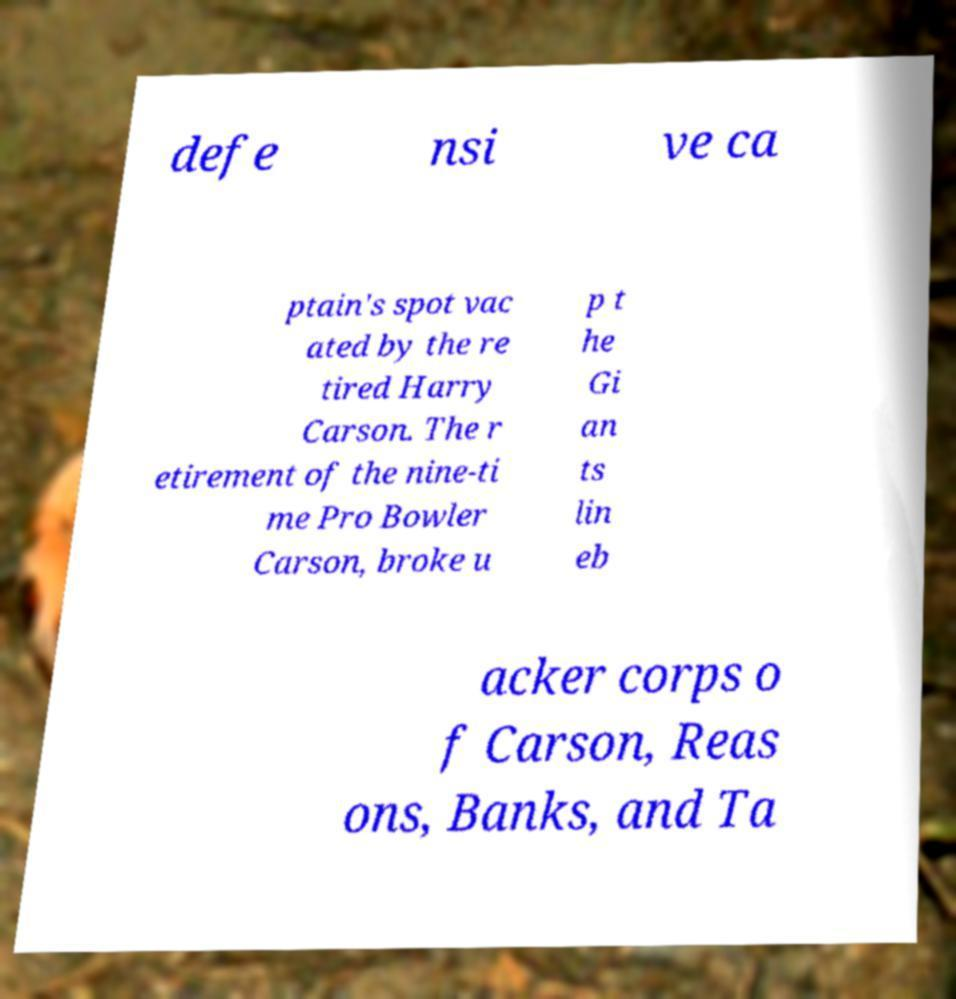Can you accurately transcribe the text from the provided image for me? defe nsi ve ca ptain's spot vac ated by the re tired Harry Carson. The r etirement of the nine-ti me Pro Bowler Carson, broke u p t he Gi an ts lin eb acker corps o f Carson, Reas ons, Banks, and Ta 